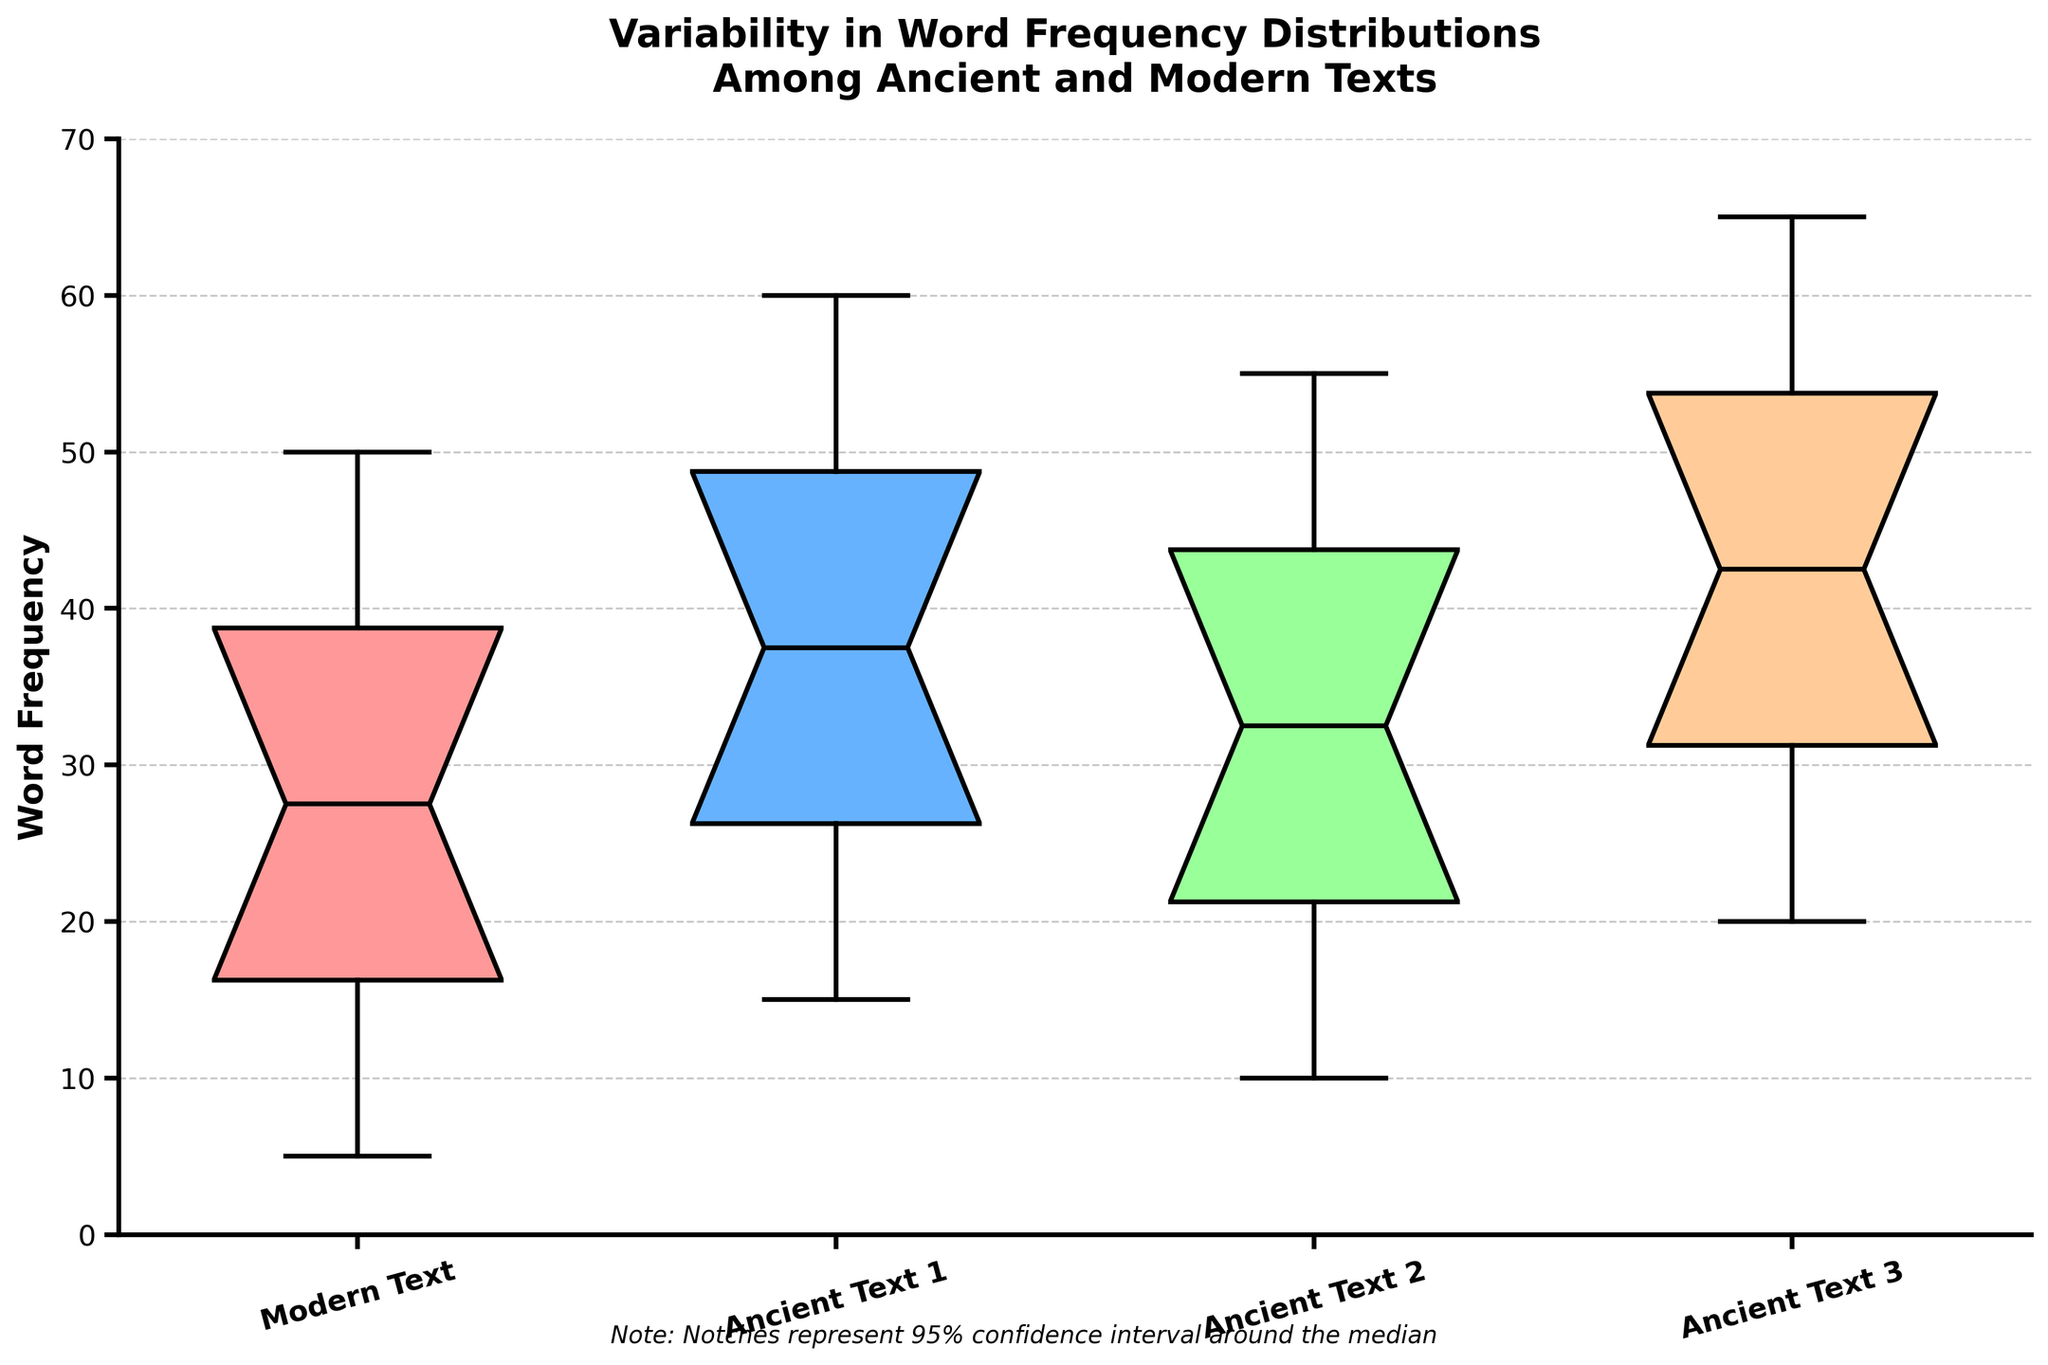What's the title of the figure? The title of the figure is clearly stated at the top, providing an overview of what the visual represents.
Answer: Variability in Word Frequency Distributions Among Ancient and Modern Texts What does the y-axis represent? The y-axis represents the metric being measured, which is indicated by the axis label.
Answer: Word Frequency How many different text groups are compared in the figure? Each box plot represents a different group, and the labels for these groups are shown on the x-axis.
Answer: Four Which text group has the lowest median word frequency? The median can be identified by locating the central line within each box plot; the group with the lowest median line is the answer.
Answer: Modern Text Which text group shows the most variability in word frequency? Variability can be assessed by looking at the range of the box plots, specifically the distance between the top and bottom whiskers.
Answer: Ancient Text 3 What is the range of word frequencies for Modern Text? The range is found by identifying the highest and lowest whiskers of the Modern Text box plot and subtracting the lowest value from the highest.
Answer: 45 - 5 = 40 How do the median word frequencies of Ancient Text 1 and Ancient Text 3 compare? The central lines (medians) of the box plots for Ancient Text 1 and Ancient Text 3 give the necessary information for this comparison.
Answer: Ancient Text 3 is higher Which text group has the smallest interquartile range (IQR)? The IQR is the distance between the bottom and top of each box (the first and third quartiles). The smallest box width indicates the smallest IQR.
Answer: Modern Text What does the notch in each box plot represent? The notches represent a specific statistical measure as mentioned in the figure's note, and indicate the precision around the median values.
Answer: 95% confidence interval around the median Between which groups is there overlap in the notches? Observing overlap in the notches of different box plots can indicate whether their medians are statistically distinguishable.
Answer: All groups overlap 